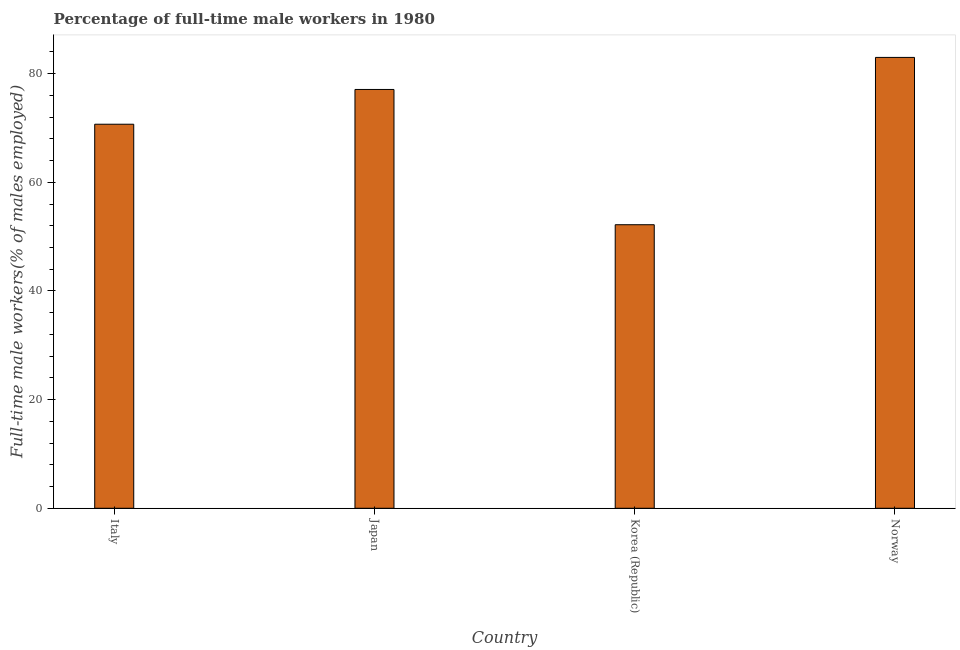What is the title of the graph?
Provide a short and direct response. Percentage of full-time male workers in 1980. What is the label or title of the X-axis?
Ensure brevity in your answer.  Country. What is the label or title of the Y-axis?
Your answer should be very brief. Full-time male workers(% of males employed). What is the percentage of full-time male workers in Norway?
Give a very brief answer. 83. Across all countries, what is the minimum percentage of full-time male workers?
Keep it short and to the point. 52.2. In which country was the percentage of full-time male workers maximum?
Offer a terse response. Norway. What is the sum of the percentage of full-time male workers?
Your response must be concise. 283. What is the difference between the percentage of full-time male workers in Italy and Japan?
Your answer should be compact. -6.4. What is the average percentage of full-time male workers per country?
Make the answer very short. 70.75. What is the median percentage of full-time male workers?
Your response must be concise. 73.9. What is the ratio of the percentage of full-time male workers in Korea (Republic) to that in Norway?
Keep it short and to the point. 0.63. Is the percentage of full-time male workers in Korea (Republic) less than that in Norway?
Give a very brief answer. Yes. Is the sum of the percentage of full-time male workers in Italy and Norway greater than the maximum percentage of full-time male workers across all countries?
Provide a succinct answer. Yes. What is the difference between the highest and the lowest percentage of full-time male workers?
Your response must be concise. 30.8. How many bars are there?
Provide a short and direct response. 4. Are all the bars in the graph horizontal?
Your response must be concise. No. How many countries are there in the graph?
Provide a succinct answer. 4. What is the Full-time male workers(% of males employed) of Italy?
Your answer should be compact. 70.7. What is the Full-time male workers(% of males employed) in Japan?
Provide a short and direct response. 77.1. What is the Full-time male workers(% of males employed) of Korea (Republic)?
Your answer should be compact. 52.2. What is the difference between the Full-time male workers(% of males employed) in Italy and Norway?
Give a very brief answer. -12.3. What is the difference between the Full-time male workers(% of males employed) in Japan and Korea (Republic)?
Your response must be concise. 24.9. What is the difference between the Full-time male workers(% of males employed) in Korea (Republic) and Norway?
Provide a short and direct response. -30.8. What is the ratio of the Full-time male workers(% of males employed) in Italy to that in Japan?
Offer a very short reply. 0.92. What is the ratio of the Full-time male workers(% of males employed) in Italy to that in Korea (Republic)?
Your answer should be compact. 1.35. What is the ratio of the Full-time male workers(% of males employed) in Italy to that in Norway?
Offer a very short reply. 0.85. What is the ratio of the Full-time male workers(% of males employed) in Japan to that in Korea (Republic)?
Make the answer very short. 1.48. What is the ratio of the Full-time male workers(% of males employed) in Japan to that in Norway?
Make the answer very short. 0.93. What is the ratio of the Full-time male workers(% of males employed) in Korea (Republic) to that in Norway?
Offer a very short reply. 0.63. 